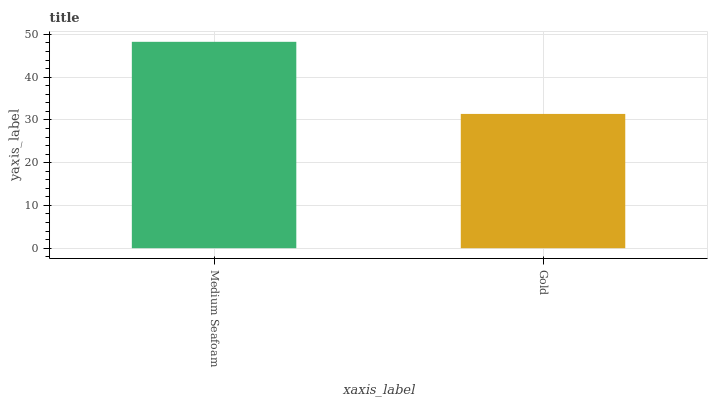Is Gold the minimum?
Answer yes or no. Yes. Is Medium Seafoam the maximum?
Answer yes or no. Yes. Is Gold the maximum?
Answer yes or no. No. Is Medium Seafoam greater than Gold?
Answer yes or no. Yes. Is Gold less than Medium Seafoam?
Answer yes or no. Yes. Is Gold greater than Medium Seafoam?
Answer yes or no. No. Is Medium Seafoam less than Gold?
Answer yes or no. No. Is Medium Seafoam the high median?
Answer yes or no. Yes. Is Gold the low median?
Answer yes or no. Yes. Is Gold the high median?
Answer yes or no. No. Is Medium Seafoam the low median?
Answer yes or no. No. 